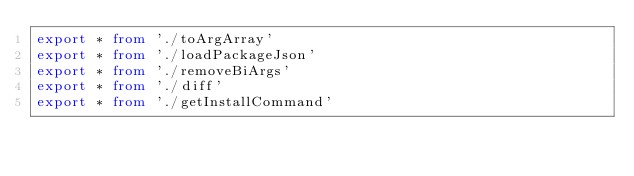<code> <loc_0><loc_0><loc_500><loc_500><_TypeScript_>export * from './toArgArray'
export * from './loadPackageJson'
export * from './removeBiArgs'
export * from './diff'
export * from './getInstallCommand'
</code> 